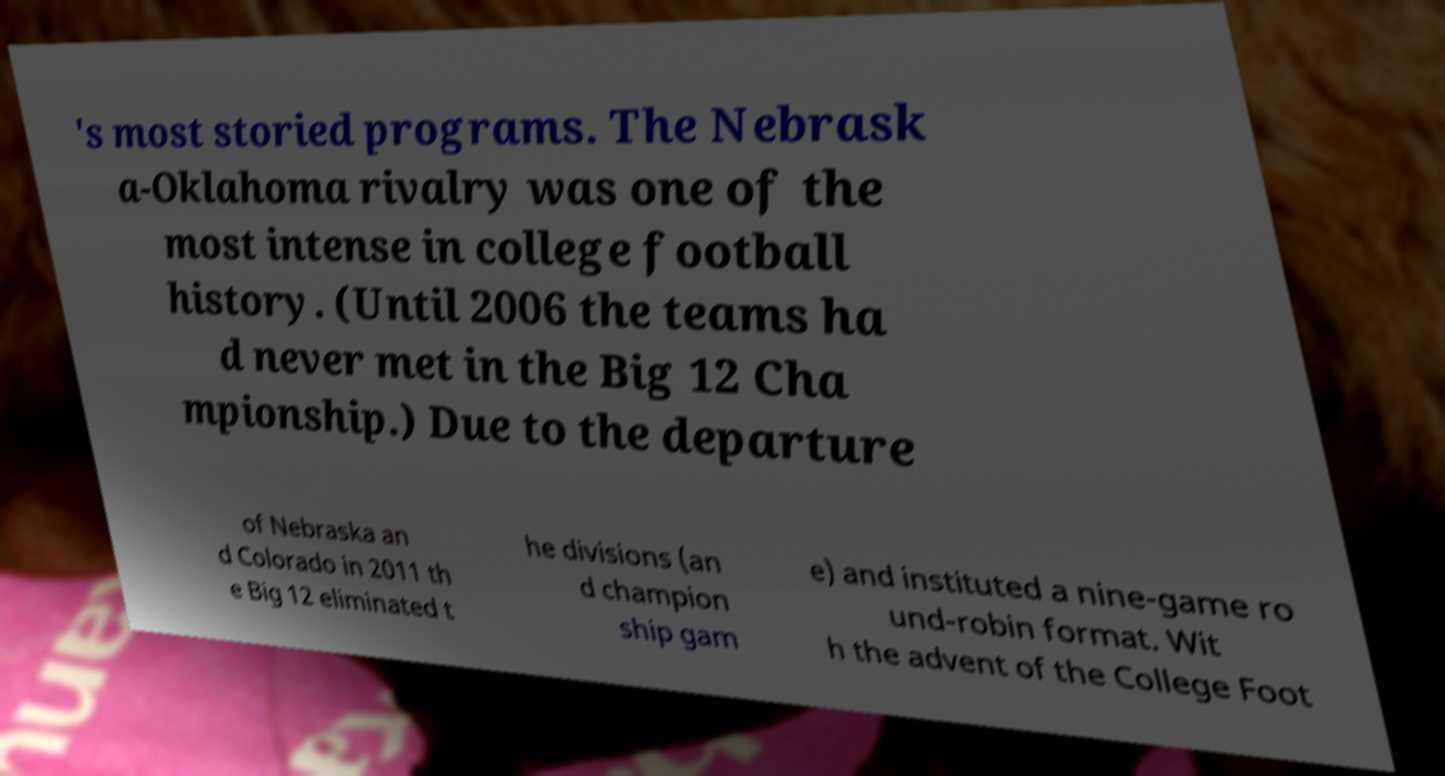Can you read and provide the text displayed in the image?This photo seems to have some interesting text. Can you extract and type it out for me? 's most storied programs. The Nebrask a-Oklahoma rivalry was one of the most intense in college football history. (Until 2006 the teams ha d never met in the Big 12 Cha mpionship.) Due to the departure of Nebraska an d Colorado in 2011 th e Big 12 eliminated t he divisions (an d champion ship gam e) and instituted a nine-game ro und-robin format. Wit h the advent of the College Foot 